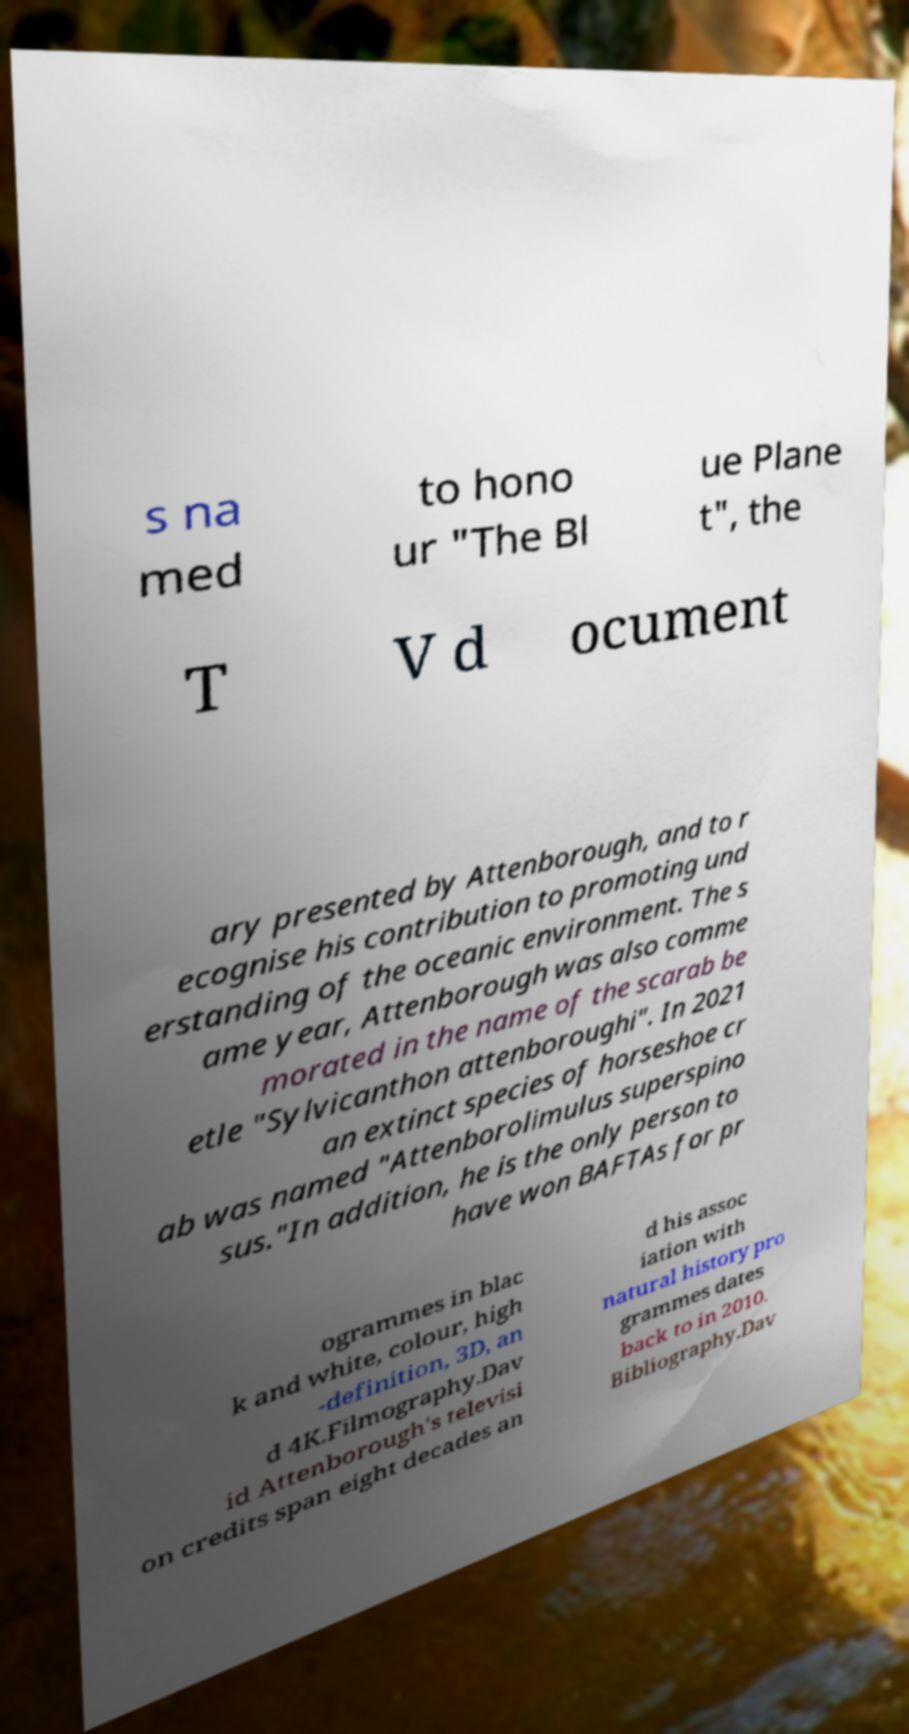Please identify and transcribe the text found in this image. s na med to hono ur "The Bl ue Plane t", the T V d ocument ary presented by Attenborough, and to r ecognise his contribution to promoting und erstanding of the oceanic environment. The s ame year, Attenborough was also comme morated in the name of the scarab be etle "Sylvicanthon attenboroughi". In 2021 an extinct species of horseshoe cr ab was named "Attenborolimulus superspino sus."In addition, he is the only person to have won BAFTAs for pr ogrammes in blac k and white, colour, high -definition, 3D, an d 4K.Filmography.Dav id Attenborough's televisi on credits span eight decades an d his assoc iation with natural history pro grammes dates back to in 2010. Bibliography.Dav 